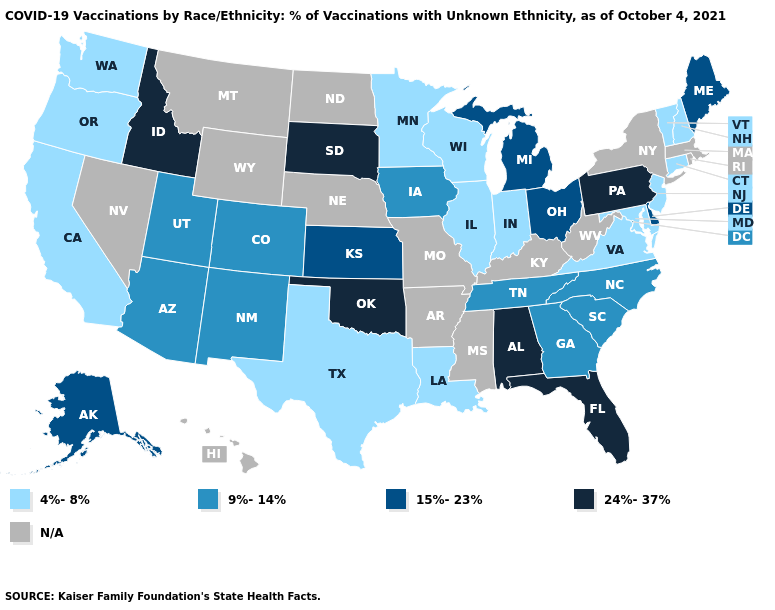Does Washington have the lowest value in the USA?
Short answer required. Yes. What is the lowest value in states that border Texas?
Answer briefly. 4%-8%. Does the first symbol in the legend represent the smallest category?
Be succinct. Yes. What is the highest value in the West ?
Be succinct. 24%-37%. What is the value of Idaho?
Concise answer only. 24%-37%. Does Connecticut have the lowest value in the USA?
Concise answer only. Yes. What is the highest value in the Northeast ?
Give a very brief answer. 24%-37%. Name the states that have a value in the range 24%-37%?
Keep it brief. Alabama, Florida, Idaho, Oklahoma, Pennsylvania, South Dakota. Name the states that have a value in the range 4%-8%?
Be succinct. California, Connecticut, Illinois, Indiana, Louisiana, Maryland, Minnesota, New Hampshire, New Jersey, Oregon, Texas, Vermont, Virginia, Washington, Wisconsin. How many symbols are there in the legend?
Write a very short answer. 5. Name the states that have a value in the range 24%-37%?
Answer briefly. Alabama, Florida, Idaho, Oklahoma, Pennsylvania, South Dakota. Name the states that have a value in the range 4%-8%?
Concise answer only. California, Connecticut, Illinois, Indiana, Louisiana, Maryland, Minnesota, New Hampshire, New Jersey, Oregon, Texas, Vermont, Virginia, Washington, Wisconsin. What is the highest value in the USA?
Keep it brief. 24%-37%. What is the lowest value in the South?
Concise answer only. 4%-8%. 